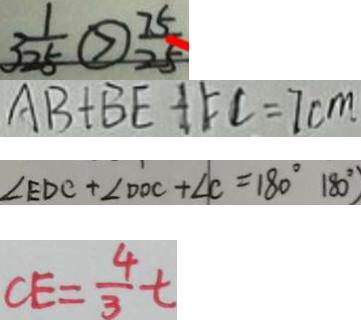<formula> <loc_0><loc_0><loc_500><loc_500>3 \frac { 1 } { 2 5 } \textcircled { > } \frac { 7 5 } { 2 5 } 
 A B + B E + F C = 7 c m 
 \angle E D C + \angle D O C + \angle C = 1 8 0 ^ { \circ } 1 8 0 ^ { \circ } ) 
 C E = \frac { 4 } { 3 } t</formula> 